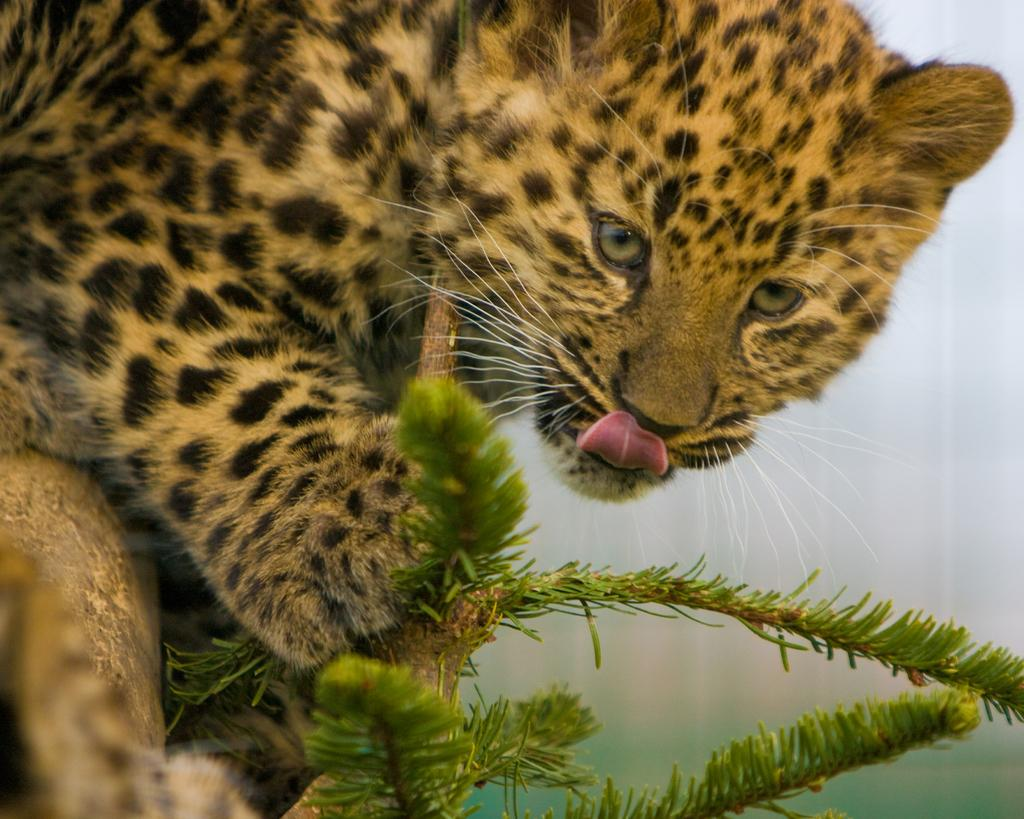What type of animal is in the image? There is a baby leopard in the image. Where is the baby leopard located? The baby leopard is on a plant. Can you describe the background of the image? The background of the image is blurred. What type of stew is being prepared in the image? There is no stew present in the image; it features a baby leopard on a plant with a blurred background. 